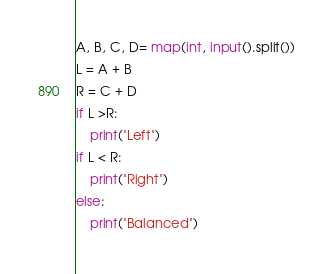<code> <loc_0><loc_0><loc_500><loc_500><_Python_>A, B, C, D= map(int, input().split())
L = A + B
R = C + D
if L >R:
    print("Left")
if L < R:
    print("Right")
else:
    print("Balanced")</code> 